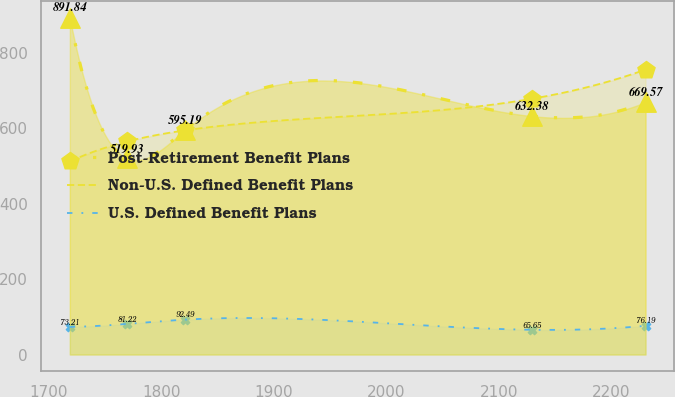Convert chart to OTSL. <chart><loc_0><loc_0><loc_500><loc_500><line_chart><ecel><fcel>Post-Retirement Benefit Plans<fcel>Non-U.S. Defined Benefit Plans<fcel>U.S. Defined Benefit Plans<nl><fcel>1718.66<fcel>891.84<fcel>512.19<fcel>73.21<nl><fcel>1769.83<fcel>519.93<fcel>565.18<fcel>81.22<nl><fcel>1821<fcel>595.19<fcel>594.43<fcel>92.49<nl><fcel>2129.01<fcel>632.38<fcel>678.01<fcel>65.65<nl><fcel>2230.33<fcel>669.57<fcel>755.5<fcel>76.19<nl></chart> 